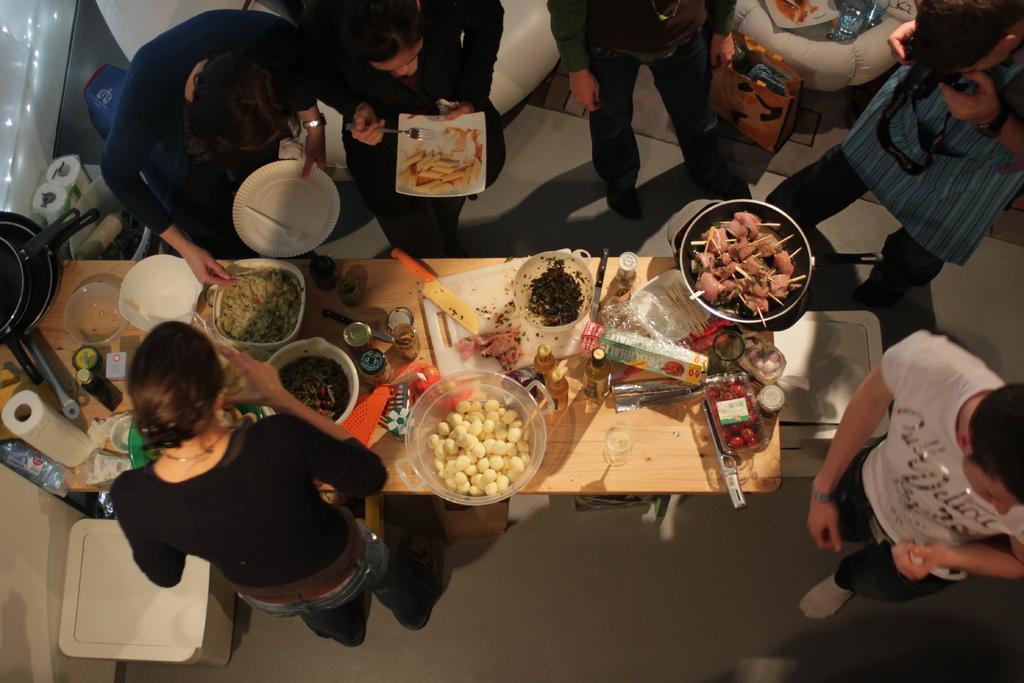Please provide a concise description of this image. In this image I see few people who are standing and I see that these 2 persons are holding plates in their hands and I see this person is holding a camera in hands and I see the table on which there are number of food items and I see the floor and I see few utensils over here. 